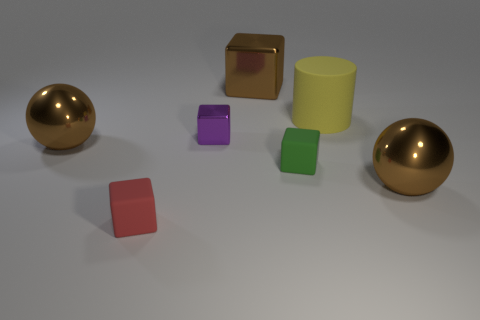Is there anything else that is the same shape as the yellow object?
Make the answer very short. No. Is the shape of the purple object the same as the yellow rubber thing?
Give a very brief answer. No. What number of other objects are there of the same size as the yellow thing?
Your response must be concise. 3. What color is the rubber cylinder?
Provide a short and direct response. Yellow. How many large objects are purple blocks or green metallic cubes?
Ensure brevity in your answer.  0. There is a rubber thing that is left of the purple object; is its size the same as the metal thing on the right side of the green rubber thing?
Your answer should be compact. No. What size is the brown thing that is the same shape as the red object?
Make the answer very short. Large. Is the number of large brown spheres left of the big rubber thing greater than the number of big cylinders to the left of the purple cube?
Give a very brief answer. Yes. What is the material of the thing that is left of the small shiny thing and behind the red cube?
Your answer should be compact. Metal. What color is the large object that is the same shape as the small shiny object?
Your answer should be compact. Brown. 